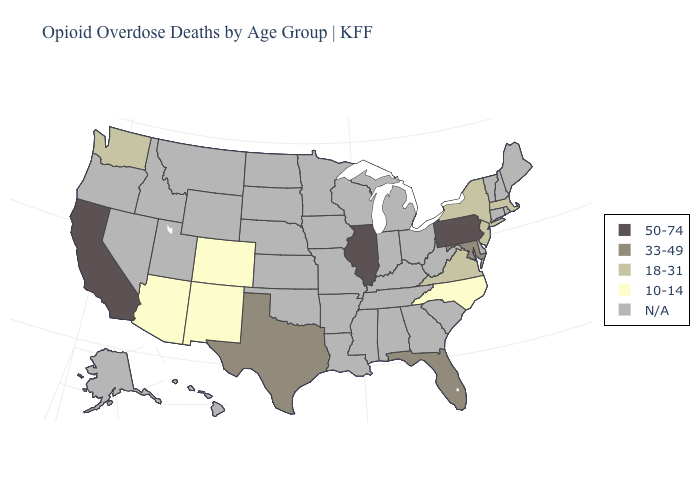Name the states that have a value in the range 33-49?
Concise answer only. Florida, Maryland, Texas. Does Massachusetts have the highest value in the USA?
Be succinct. No. Name the states that have a value in the range N/A?
Be succinct. Alabama, Alaska, Arkansas, Connecticut, Delaware, Georgia, Hawaii, Idaho, Indiana, Iowa, Kansas, Kentucky, Louisiana, Maine, Michigan, Minnesota, Mississippi, Missouri, Montana, Nebraska, Nevada, New Hampshire, North Dakota, Ohio, Oklahoma, Oregon, Rhode Island, South Carolina, South Dakota, Tennessee, Utah, Vermont, West Virginia, Wisconsin, Wyoming. Does Texas have the highest value in the South?
Give a very brief answer. Yes. Does Pennsylvania have the highest value in the USA?
Write a very short answer. Yes. How many symbols are there in the legend?
Be succinct. 5. Name the states that have a value in the range 33-49?
Answer briefly. Florida, Maryland, Texas. Does Pennsylvania have the highest value in the USA?
Short answer required. Yes. What is the value of Missouri?
Keep it brief. N/A. Is the legend a continuous bar?
Write a very short answer. No. Which states have the highest value in the USA?
Give a very brief answer. California, Illinois, Pennsylvania. Name the states that have a value in the range N/A?
Concise answer only. Alabama, Alaska, Arkansas, Connecticut, Delaware, Georgia, Hawaii, Idaho, Indiana, Iowa, Kansas, Kentucky, Louisiana, Maine, Michigan, Minnesota, Mississippi, Missouri, Montana, Nebraska, Nevada, New Hampshire, North Dakota, Ohio, Oklahoma, Oregon, Rhode Island, South Carolina, South Dakota, Tennessee, Utah, Vermont, West Virginia, Wisconsin, Wyoming. What is the highest value in states that border Nebraska?
Concise answer only. 10-14. Does Pennsylvania have the lowest value in the Northeast?
Write a very short answer. No. 